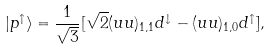<formula> <loc_0><loc_0><loc_500><loc_500>| p ^ { \uparrow } \rangle = { \frac { 1 } { \sqrt { 3 } } } [ \sqrt { 2 } ( u u ) _ { 1 , 1 } d ^ { \downarrow } - ( u u ) _ { 1 , 0 } d ^ { \uparrow } ] ,</formula> 